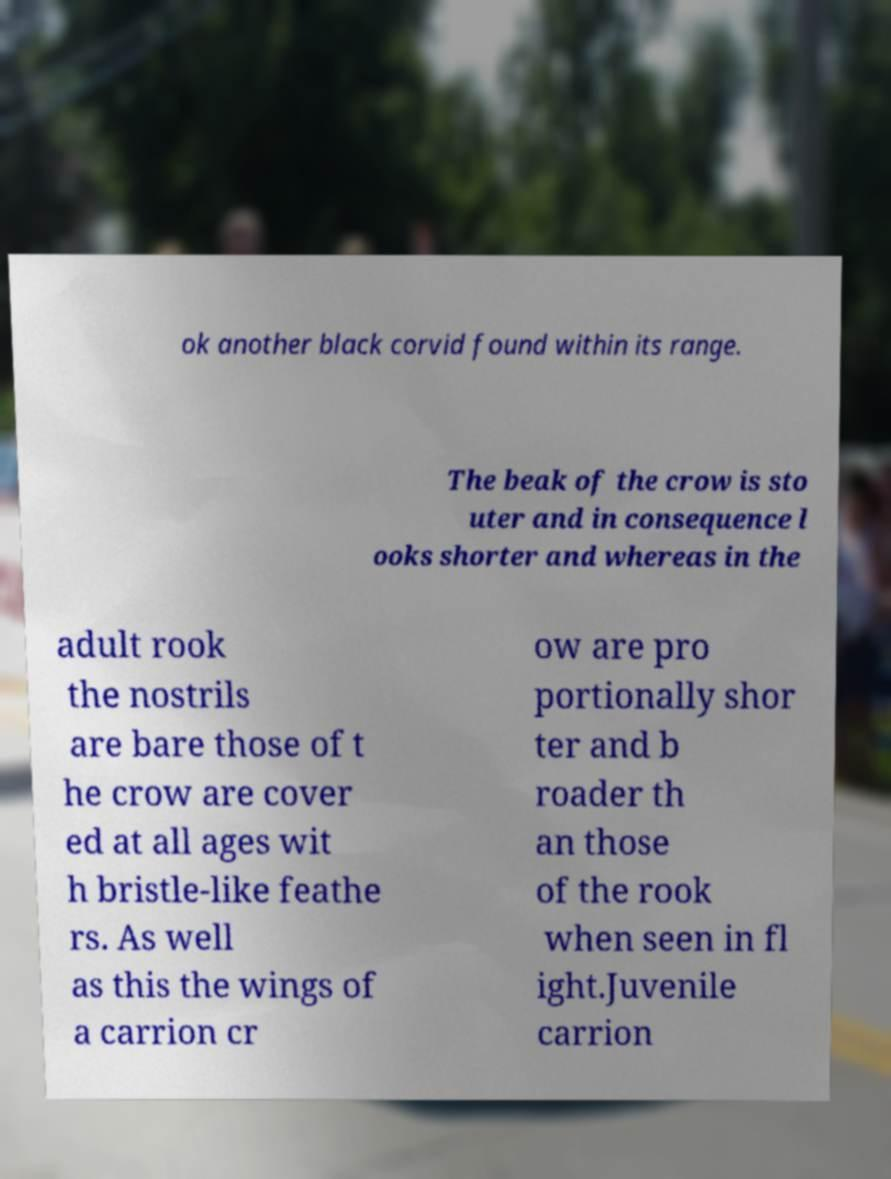What messages or text are displayed in this image? I need them in a readable, typed format. ok another black corvid found within its range. The beak of the crow is sto uter and in consequence l ooks shorter and whereas in the adult rook the nostrils are bare those of t he crow are cover ed at all ages wit h bristle-like feathe rs. As well as this the wings of a carrion cr ow are pro portionally shor ter and b roader th an those of the rook when seen in fl ight.Juvenile carrion 